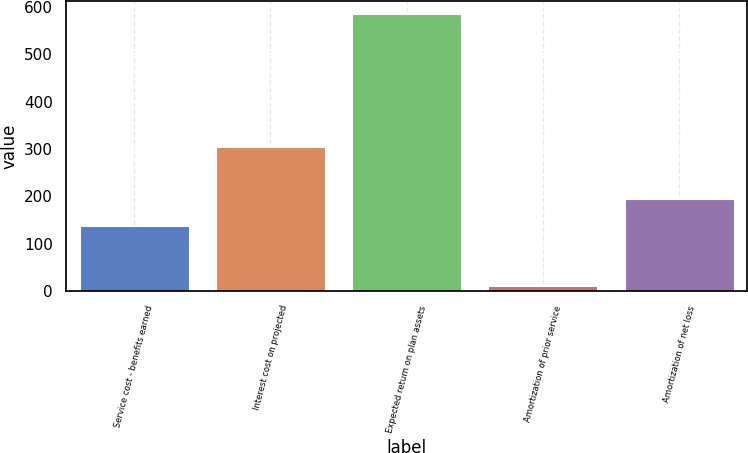Convert chart. <chart><loc_0><loc_0><loc_500><loc_500><bar_chart><fcel>Service cost - benefits earned<fcel>Interest cost on projected<fcel>Expected return on plan assets<fcel>Amortization of prior service<fcel>Amortization of net loss<nl><fcel>138<fcel>304<fcel>584<fcel>10<fcel>195.4<nl></chart> 